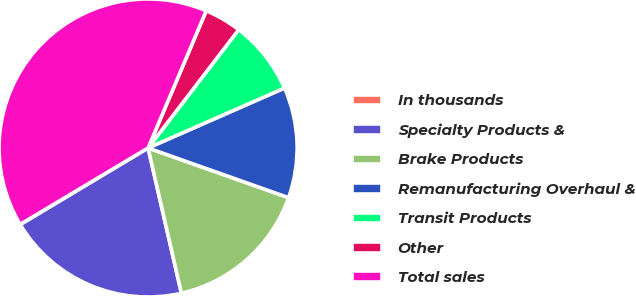<chart> <loc_0><loc_0><loc_500><loc_500><pie_chart><fcel>In thousands<fcel>Specialty Products &<fcel>Brake Products<fcel>Remanufacturing Overhaul &<fcel>Transit Products<fcel>Other<fcel>Total sales<nl><fcel>0.03%<fcel>19.99%<fcel>16.0%<fcel>12.0%<fcel>8.01%<fcel>4.02%<fcel>39.95%<nl></chart> 